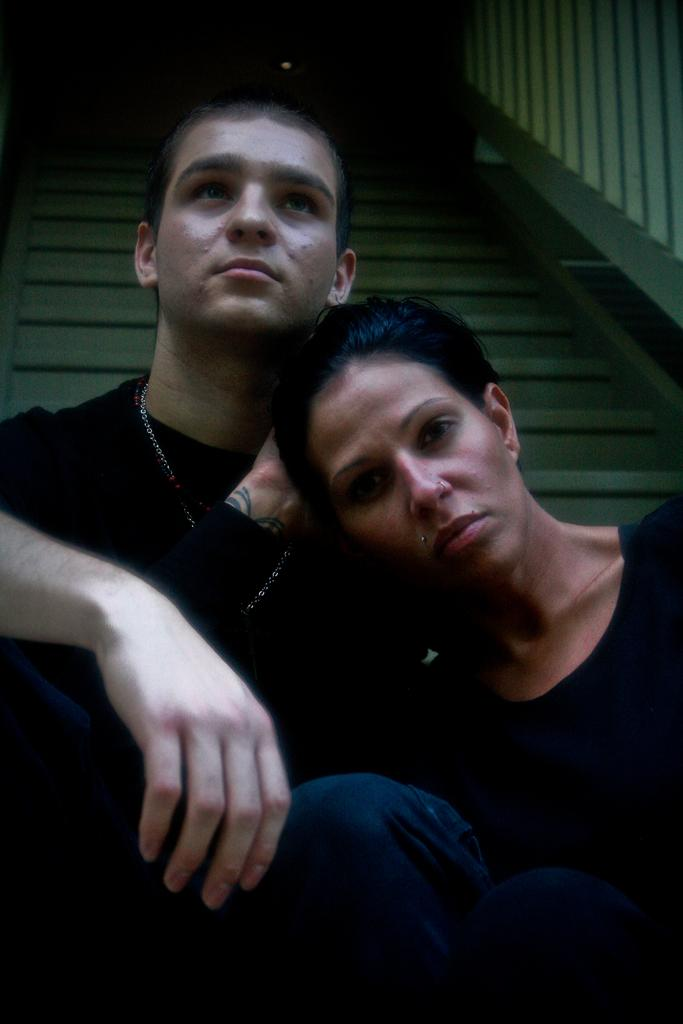Who can be seen in the image? There is a man and a lady in the image. What are the man and lady doing in the image? The man and lady are sitting. What can be seen in the background of the image? There are stairs in the background of the image. What type of basketball is the man holding in the image? There is no basketball present in the image. What word is written on the lady's shirt in the image? We cannot determine any words on the lady's shirt from the image. What type of skin condition is visible on the man's face in the image? There is no mention of any skin condition visible on the man's face in the image. 